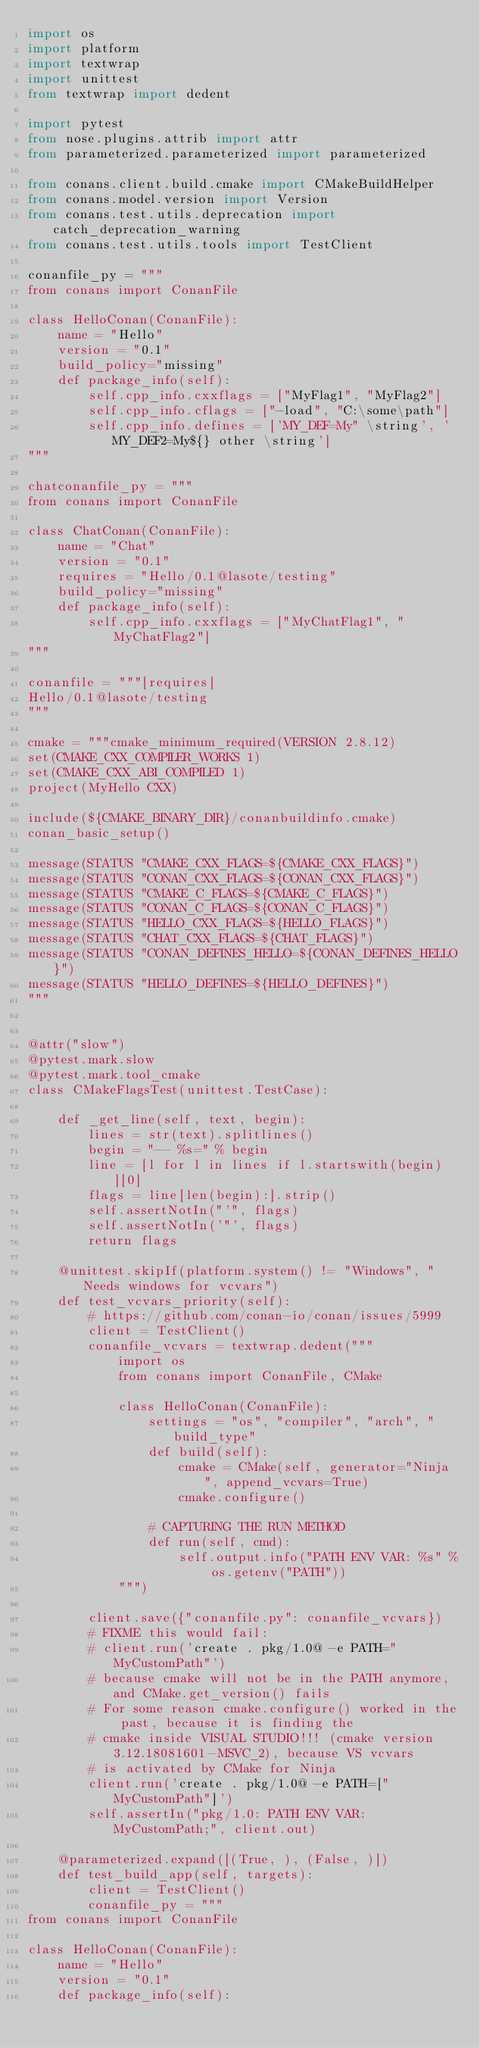Convert code to text. <code><loc_0><loc_0><loc_500><loc_500><_Python_>import os
import platform
import textwrap
import unittest
from textwrap import dedent

import pytest
from nose.plugins.attrib import attr
from parameterized.parameterized import parameterized

from conans.client.build.cmake import CMakeBuildHelper
from conans.model.version import Version
from conans.test.utils.deprecation import catch_deprecation_warning
from conans.test.utils.tools import TestClient

conanfile_py = """
from conans import ConanFile

class HelloConan(ConanFile):
    name = "Hello"
    version = "0.1"
    build_policy="missing"
    def package_info(self):
        self.cpp_info.cxxflags = ["MyFlag1", "MyFlag2"]
        self.cpp_info.cflags = ["-load", "C:\some\path"]
        self.cpp_info.defines = ['MY_DEF=My" \string', 'MY_DEF2=My${} other \string']
"""

chatconanfile_py = """
from conans import ConanFile

class ChatConan(ConanFile):
    name = "Chat"
    version = "0.1"
    requires = "Hello/0.1@lasote/testing"
    build_policy="missing"
    def package_info(self):
        self.cpp_info.cxxflags = ["MyChatFlag1", "MyChatFlag2"]
"""

conanfile = """[requires]
Hello/0.1@lasote/testing
"""

cmake = """cmake_minimum_required(VERSION 2.8.12)
set(CMAKE_CXX_COMPILER_WORKS 1)
set(CMAKE_CXX_ABI_COMPILED 1)
project(MyHello CXX)

include(${CMAKE_BINARY_DIR}/conanbuildinfo.cmake)
conan_basic_setup()

message(STATUS "CMAKE_CXX_FLAGS=${CMAKE_CXX_FLAGS}")
message(STATUS "CONAN_CXX_FLAGS=${CONAN_CXX_FLAGS}")
message(STATUS "CMAKE_C_FLAGS=${CMAKE_C_FLAGS}")
message(STATUS "CONAN_C_FLAGS=${CONAN_C_FLAGS}")
message(STATUS "HELLO_CXX_FLAGS=${HELLO_FLAGS}")
message(STATUS "CHAT_CXX_FLAGS=${CHAT_FLAGS}")
message(STATUS "CONAN_DEFINES_HELLO=${CONAN_DEFINES_HELLO}")
message(STATUS "HELLO_DEFINES=${HELLO_DEFINES}")
"""


@attr("slow")
@pytest.mark.slow
@pytest.mark.tool_cmake
class CMakeFlagsTest(unittest.TestCase):

    def _get_line(self, text, begin):
        lines = str(text).splitlines()
        begin = "-- %s=" % begin
        line = [l for l in lines if l.startswith(begin)][0]
        flags = line[len(begin):].strip()
        self.assertNotIn("'", flags)
        self.assertNotIn('"', flags)
        return flags

    @unittest.skipIf(platform.system() != "Windows", "Needs windows for vcvars")
    def test_vcvars_priority(self):
        # https://github.com/conan-io/conan/issues/5999
        client = TestClient()
        conanfile_vcvars = textwrap.dedent("""
            import os
            from conans import ConanFile, CMake

            class HelloConan(ConanFile):
                settings = "os", "compiler", "arch", "build_type"
                def build(self):
                    cmake = CMake(self, generator="Ninja", append_vcvars=True)
                    cmake.configure()

                # CAPTURING THE RUN METHOD
                def run(self, cmd):
                    self.output.info("PATH ENV VAR: %s" % os.getenv("PATH"))
            """)

        client.save({"conanfile.py": conanfile_vcvars})
        # FIXME this would fail:
        # client.run('create . pkg/1.0@ -e PATH="MyCustomPath"')
        # because cmake will not be in the PATH anymore, and CMake.get_version() fails
        # For some reason cmake.configure() worked in the past, because it is finding the
        # cmake inside VISUAL STUDIO!!! (cmake version 3.12.18081601-MSVC_2), because VS vcvars
        # is activated by CMake for Ninja
        client.run('create . pkg/1.0@ -e PATH=["MyCustomPath"]')
        self.assertIn("pkg/1.0: PATH ENV VAR: MyCustomPath;", client.out)

    @parameterized.expand([(True, ), (False, )])
    def test_build_app(self, targets):
        client = TestClient()
        conanfile_py = """
from conans import ConanFile

class HelloConan(ConanFile):
    name = "Hello"
    version = "0.1"
    def package_info(self):</code> 